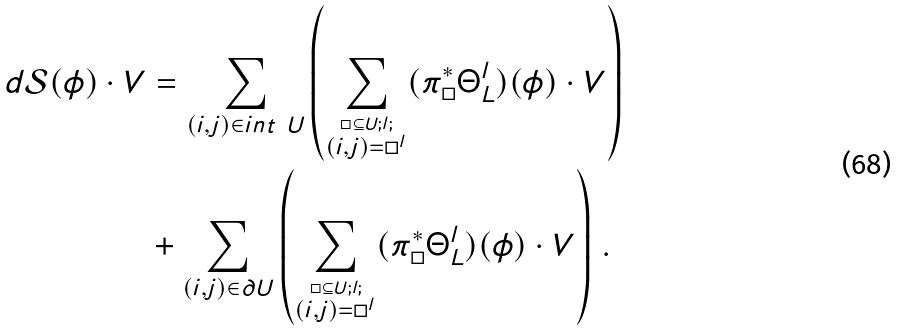Convert formula to latex. <formula><loc_0><loc_0><loc_500><loc_500>d \mathcal { S } ( \phi ) \cdot V & = \sum _ { ( i , j ) \in i n t \ U } \left ( \sum _ { \stackrel { \square \subseteq U ; l ; } { ( i , j ) = \square ^ { l } } } ( \pi _ { \square } ^ { \ast } \Theta _ { L } ^ { l } ) ( \phi ) \cdot V \right ) \\ & + \sum _ { ( i , j ) \in \partial U } \left ( \sum _ { \stackrel { \square \subseteq U ; l ; } { ( i , j ) = \square ^ { l } } } ( \pi _ { \square } ^ { \ast } \Theta _ { L } ^ { l } ) ( \phi ) \cdot V \right ) \, .</formula> 